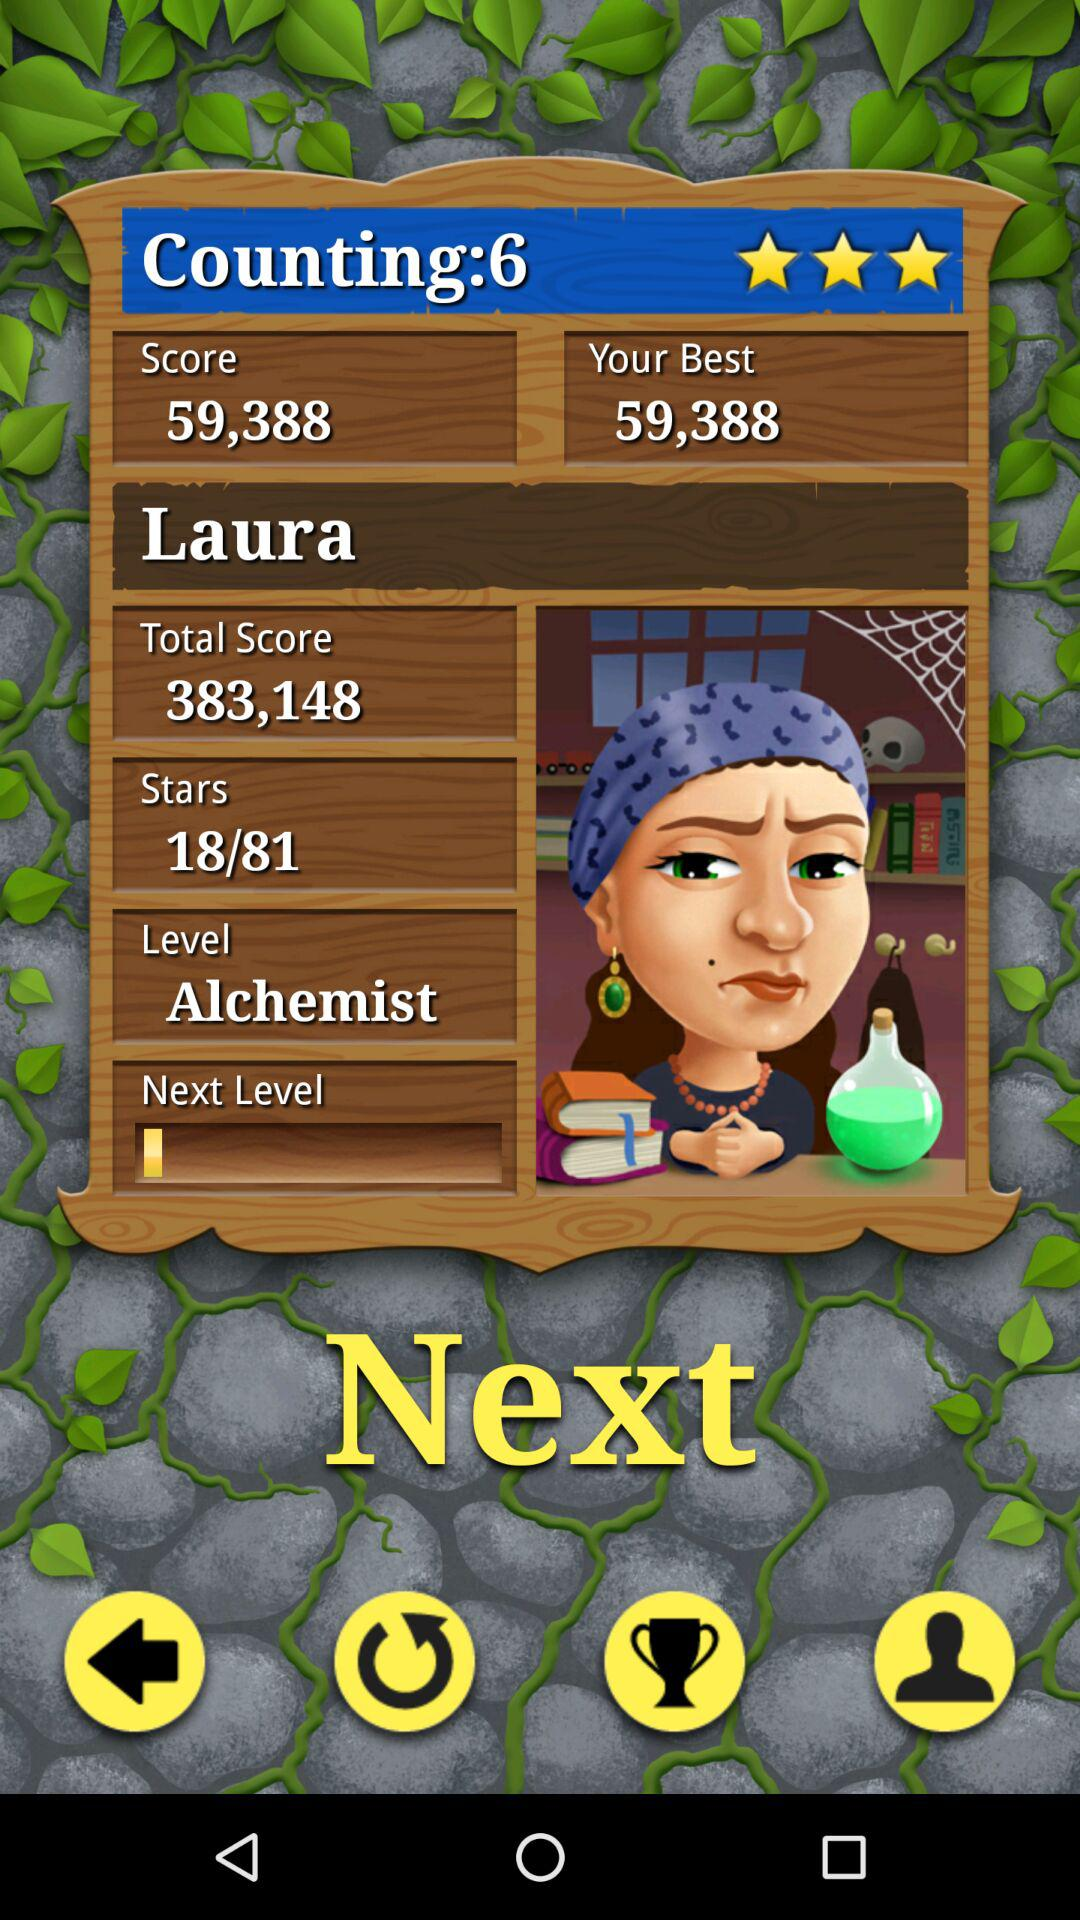What is the name of the level? The name of the level is "Alchemist". 